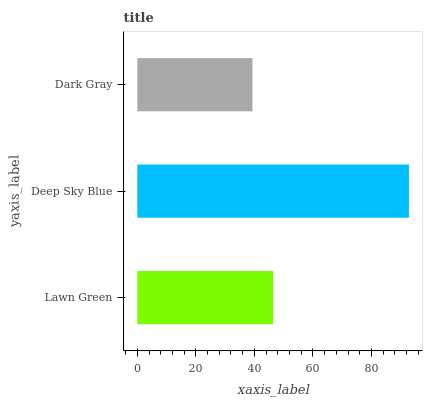Is Dark Gray the minimum?
Answer yes or no. Yes. Is Deep Sky Blue the maximum?
Answer yes or no. Yes. Is Deep Sky Blue the minimum?
Answer yes or no. No. Is Dark Gray the maximum?
Answer yes or no. No. Is Deep Sky Blue greater than Dark Gray?
Answer yes or no. Yes. Is Dark Gray less than Deep Sky Blue?
Answer yes or no. Yes. Is Dark Gray greater than Deep Sky Blue?
Answer yes or no. No. Is Deep Sky Blue less than Dark Gray?
Answer yes or no. No. Is Lawn Green the high median?
Answer yes or no. Yes. Is Lawn Green the low median?
Answer yes or no. Yes. Is Dark Gray the high median?
Answer yes or no. No. Is Dark Gray the low median?
Answer yes or no. No. 